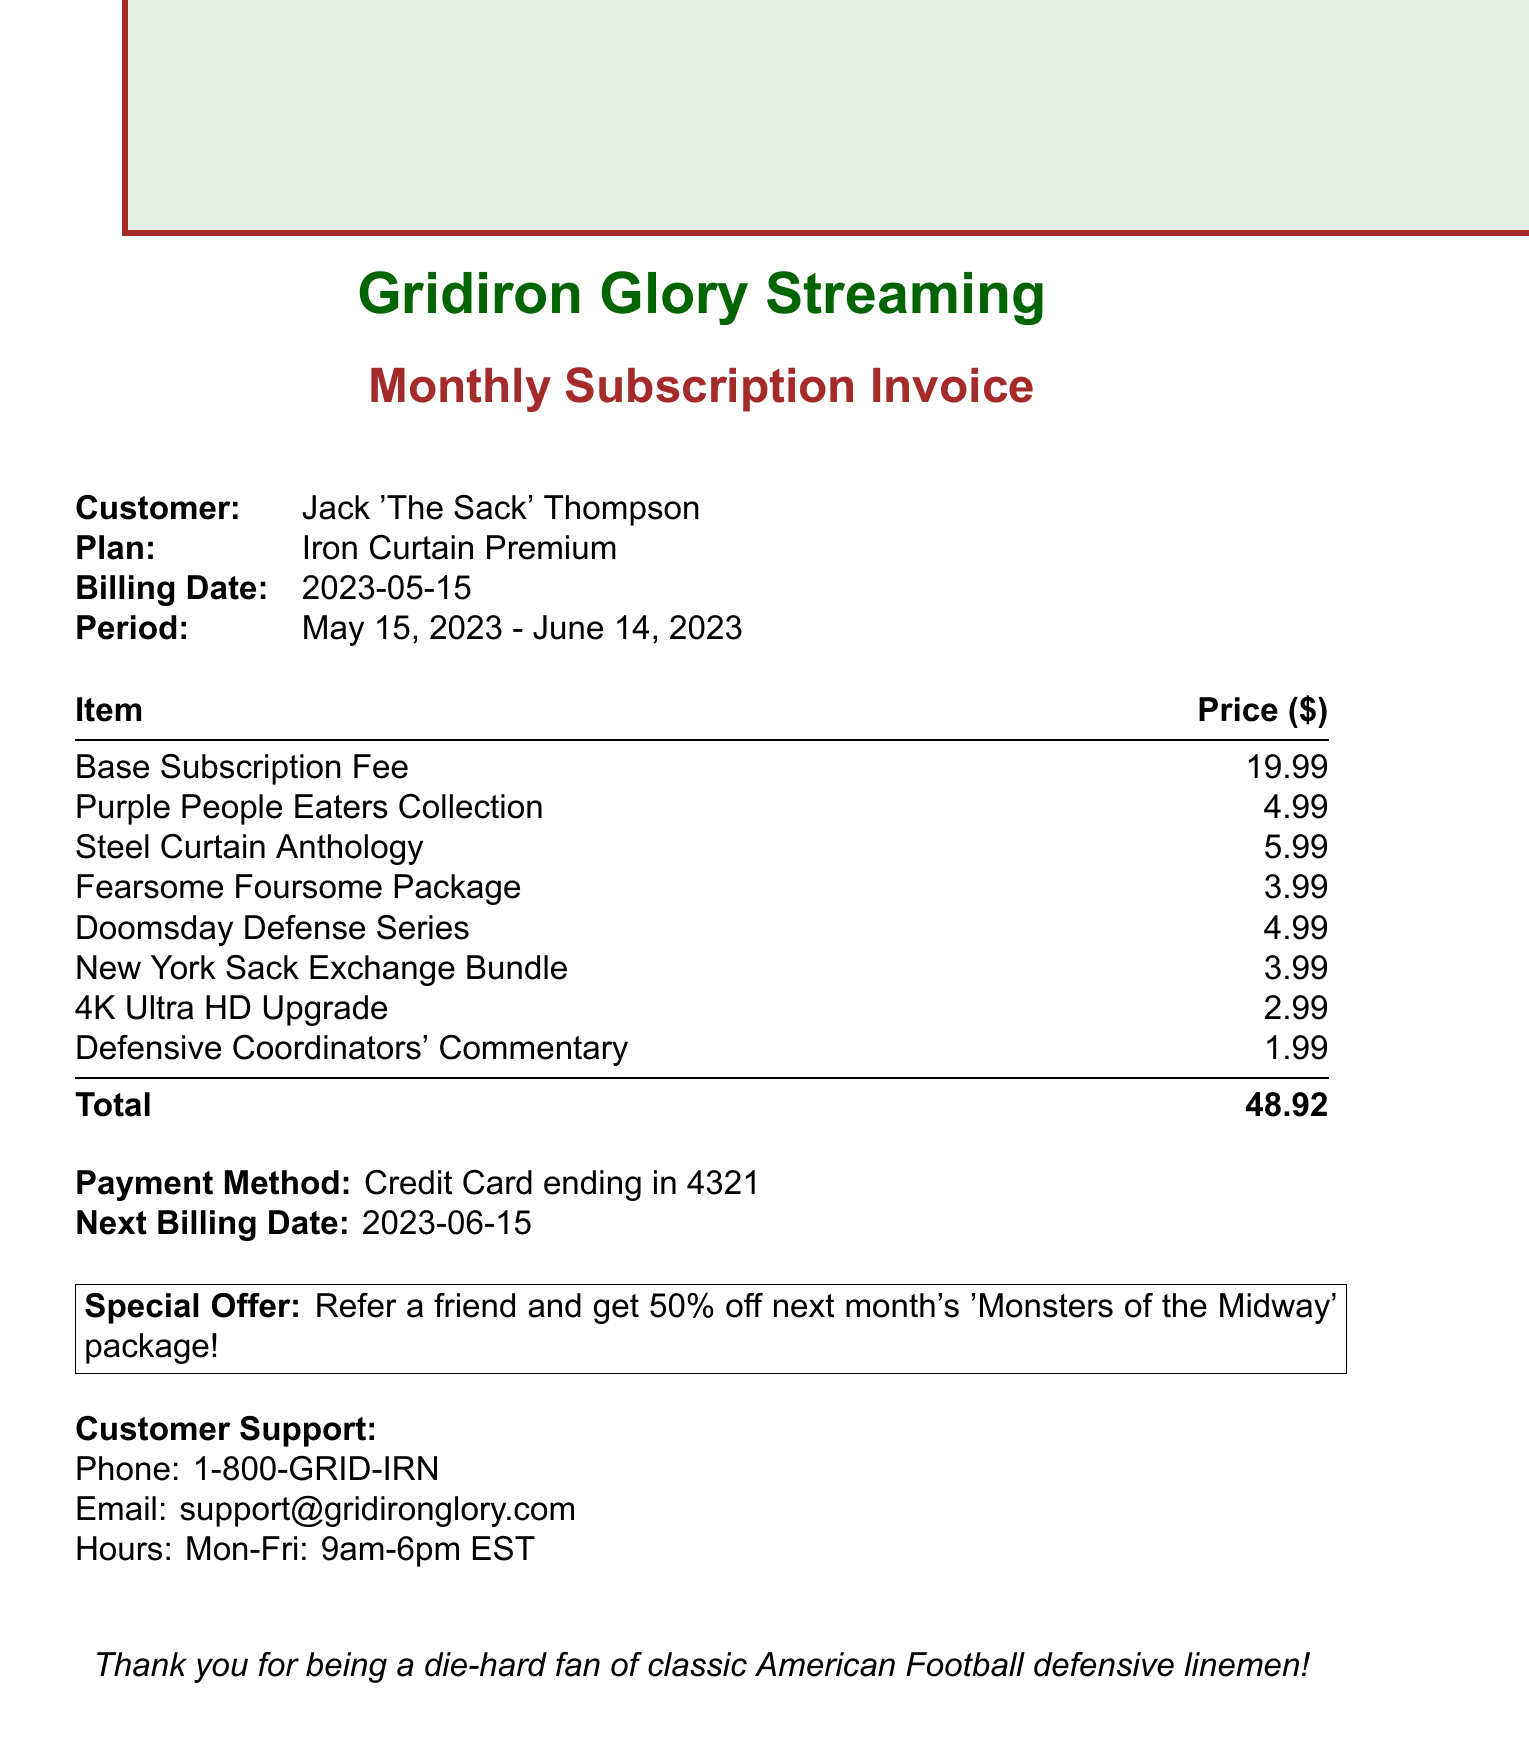What is the customer's name? The customer's name is listed at the top of the invoice under customer information.
Answer: Jack 'The Sack' Thompson What is the billing date? The billing date appears in the document under the billing information section.
Answer: 2023-05-15 What is the subscription plan? The subscription plan is mentioned in the customer information section of the invoice.
Answer: Iron Curtain Premium What is the total amount due? The total amount is prominently displayed at the end of the itemized list of charges.
Answer: 48.92 How many line items are listed? The line items can be counted from the itemized charge section of the invoice.
Answer: 6 What is the next billing date? The next billing date is provided at the end of the total section in the invoice.
Answer: 2023-06-15 What is the price of the Steel Curtain Anthology? The price of the Steel Curtain Anthology is found in the itemized list of charges.
Answer: 5.99 What special offer is mentioned? The special offer is located in a highlighted box towards the end of the document.
Answer: Refer a friend and get 50% off next month's 'Monsters of the Midway' package! What payment method was used? The payment method is indicated in the payment information section of the invoice.
Answer: Credit Card ending in 4321 What customer support hours are listed? The customer support hours are stated along with the contact information at the bottom of the invoice.
Answer: Mon-Fri: 9am-6pm EST 